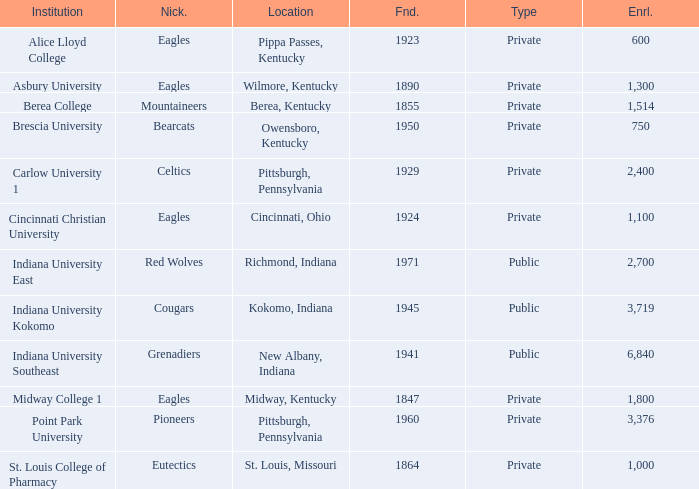Which of the private colleges is the oldest, and whose nickname is the Mountaineers? 1855.0. 